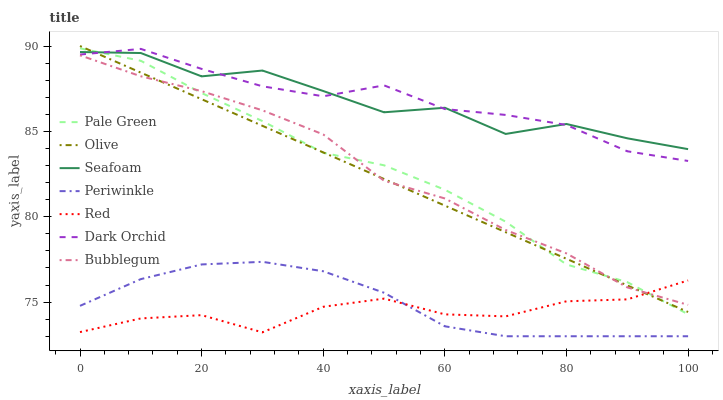Does Red have the minimum area under the curve?
Answer yes or no. Yes. Does Dark Orchid have the maximum area under the curve?
Answer yes or no. Yes. Does Pale Green have the minimum area under the curve?
Answer yes or no. No. Does Pale Green have the maximum area under the curve?
Answer yes or no. No. Is Olive the smoothest?
Answer yes or no. Yes. Is Seafoam the roughest?
Answer yes or no. Yes. Is Dark Orchid the smoothest?
Answer yes or no. No. Is Dark Orchid the roughest?
Answer yes or no. No. Does Periwinkle have the lowest value?
Answer yes or no. Yes. Does Dark Orchid have the lowest value?
Answer yes or no. No. Does Olive have the highest value?
Answer yes or no. Yes. Does Dark Orchid have the highest value?
Answer yes or no. No. Is Periwinkle less than Bubblegum?
Answer yes or no. Yes. Is Seafoam greater than Bubblegum?
Answer yes or no. Yes. Does Red intersect Olive?
Answer yes or no. Yes. Is Red less than Olive?
Answer yes or no. No. Is Red greater than Olive?
Answer yes or no. No. Does Periwinkle intersect Bubblegum?
Answer yes or no. No. 